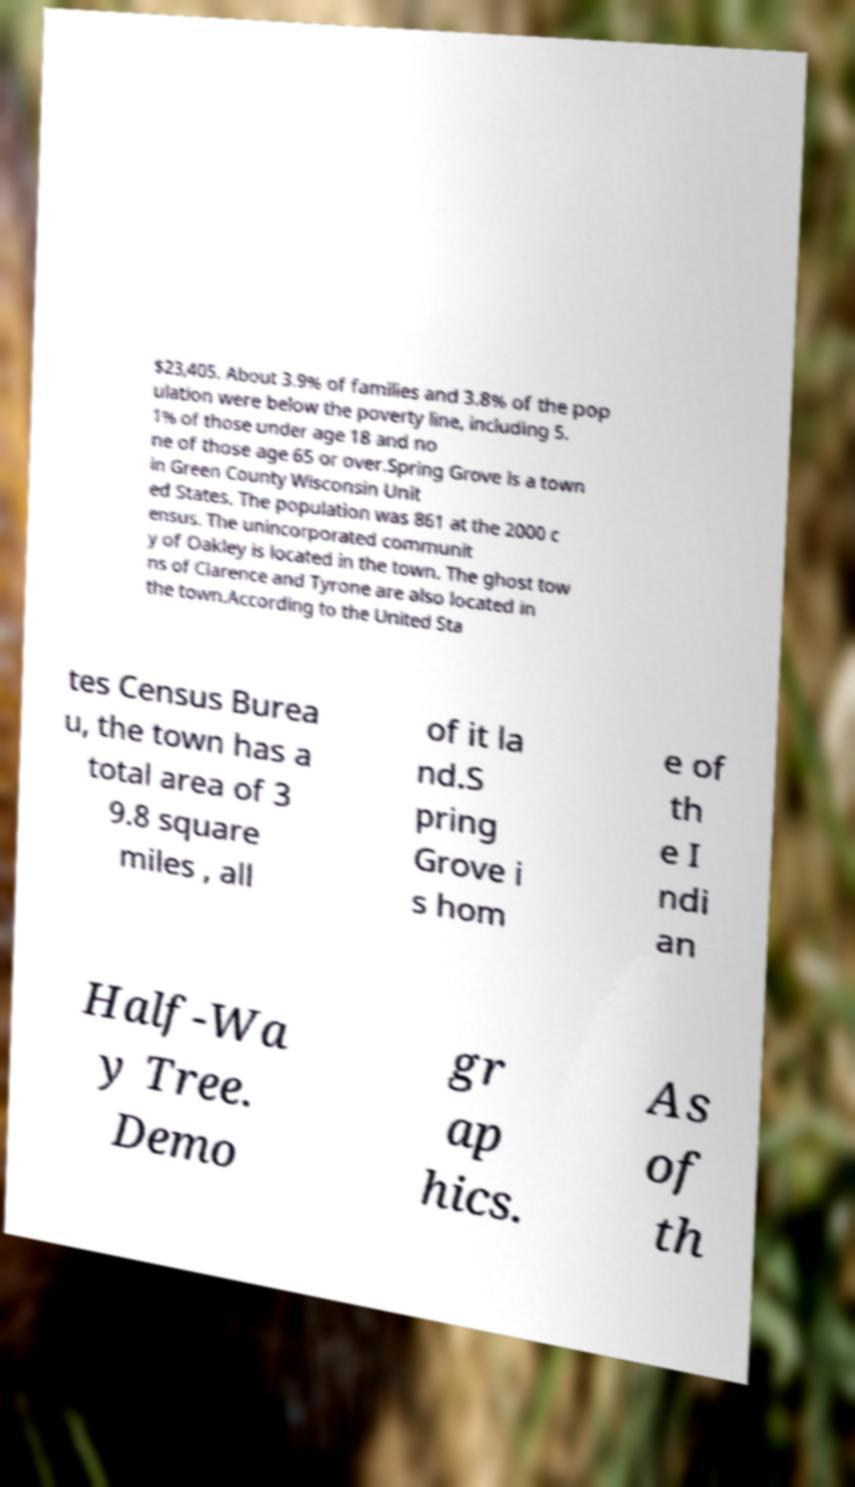Can you read and provide the text displayed in the image?This photo seems to have some interesting text. Can you extract and type it out for me? $23,405. About 3.9% of families and 3.8% of the pop ulation were below the poverty line, including 5. 1% of those under age 18 and no ne of those age 65 or over.Spring Grove is a town in Green County Wisconsin Unit ed States. The population was 861 at the 2000 c ensus. The unincorporated communit y of Oakley is located in the town. The ghost tow ns of Clarence and Tyrone are also located in the town.According to the United Sta tes Census Burea u, the town has a total area of 3 9.8 square miles , all of it la nd.S pring Grove i s hom e of th e I ndi an Half-Wa y Tree. Demo gr ap hics. As of th 